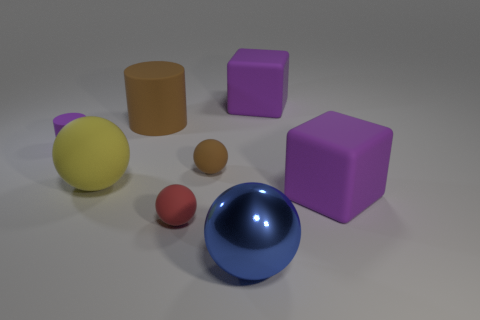Subtract all cyan balls. Subtract all cyan cylinders. How many balls are left? 4 Add 1 big yellow rubber objects. How many objects exist? 9 Subtract all cylinders. How many objects are left? 6 Add 3 tiny red things. How many tiny red things are left? 4 Add 4 yellow rubber things. How many yellow rubber things exist? 5 Subtract 0 purple balls. How many objects are left? 8 Subtract all small brown rubber spheres. Subtract all small red matte balls. How many objects are left? 6 